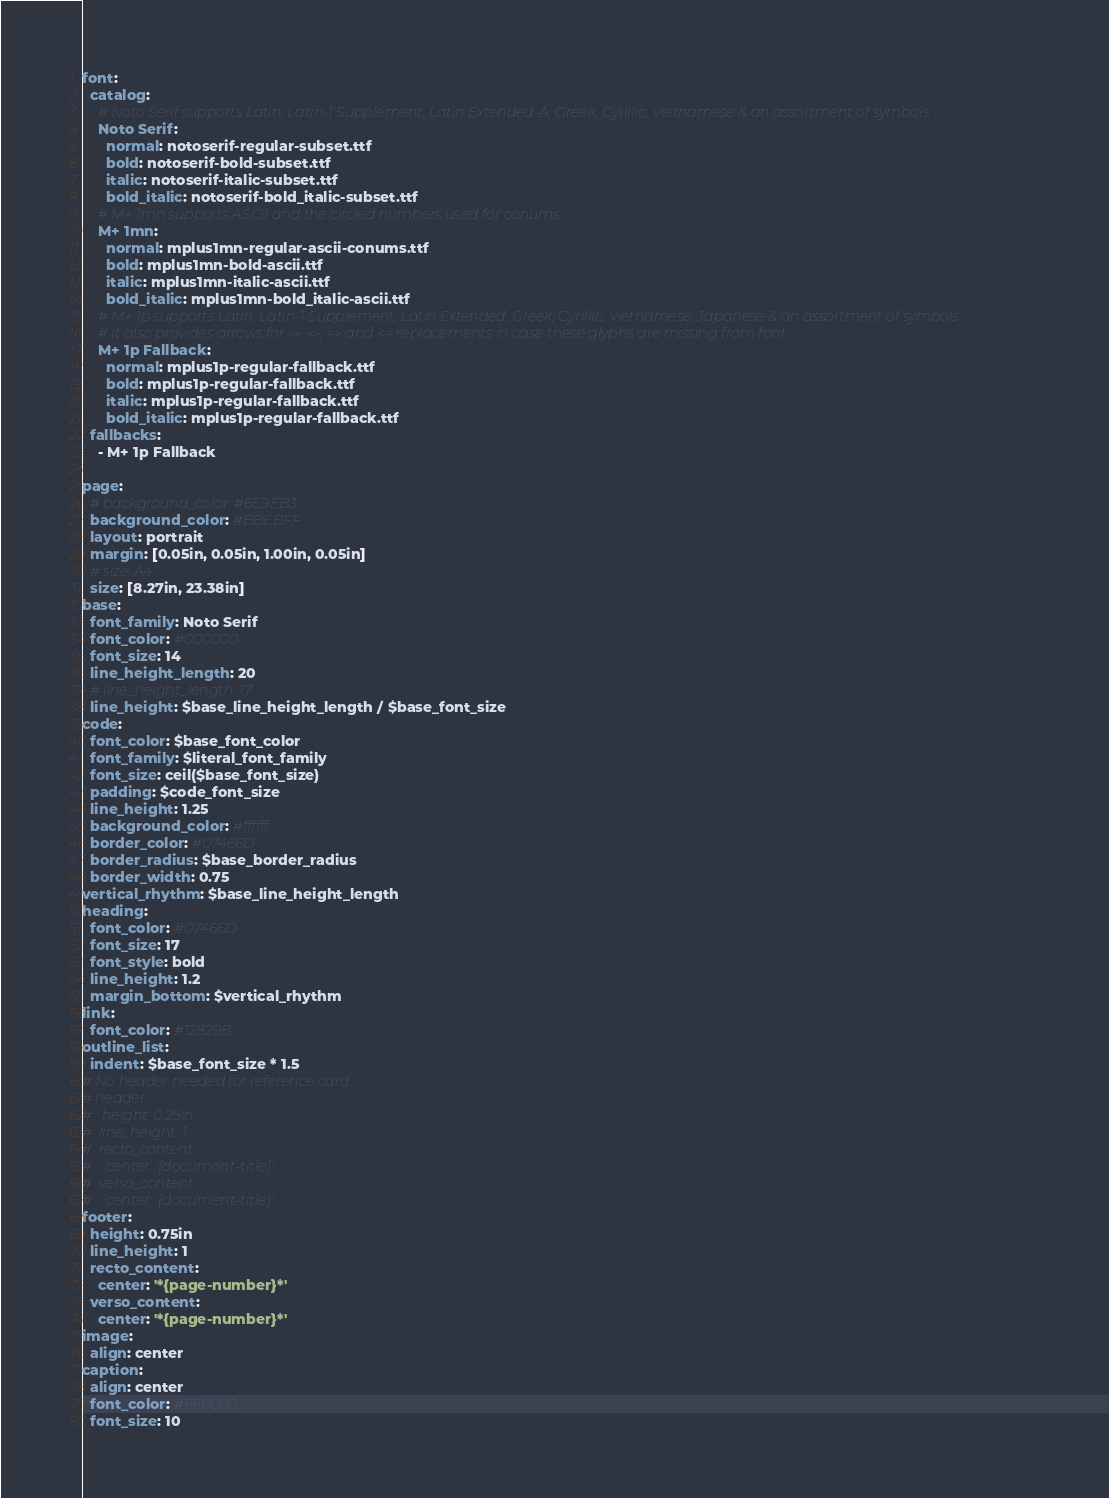Convert code to text. <code><loc_0><loc_0><loc_500><loc_500><_YAML_>font:
  catalog:
    # Noto Serif supports Latin, Latin-1 Supplement, Latin Extended-A, Greek, Cyrillic, Vietnamese & an assortment of symbols
    Noto Serif:
      normal: notoserif-regular-subset.ttf
      bold: notoserif-bold-subset.ttf
      italic: notoserif-italic-subset.ttf
      bold_italic: notoserif-bold_italic-subset.ttf
    # M+ 1mn supports ASCII and the circled numbers used for conums
    M+ 1mn:
      normal: mplus1mn-regular-ascii-conums.ttf
      bold: mplus1mn-bold-ascii.ttf
      italic: mplus1mn-italic-ascii.ttf
      bold_italic: mplus1mn-bold_italic-ascii.ttf
    # M+ 1p supports Latin, Latin-1 Supplement, Latin Extended, Greek, Cyrillic, Vietnamese, Japanese & an assortment of symbols
    # It also provides arrows for ->, <-, => and <= replacements in case these glyphs are missing from font
    M+ 1p Fallback:
      normal: mplus1p-regular-fallback.ttf
      bold: mplus1p-regular-fallback.ttf
      italic: mplus1p-regular-fallback.ttf
      bold_italic: mplus1p-regular-fallback.ttf
  fallbacks:
    - M+ 1p Fallback

page:
  # background_color: #6E9EB3
  background_color: #BBEBFF
  layout: portrait
  margin: [0.05in, 0.05in, 1.00in, 0.05in]
  # size: A4
  size: [8.27in, 23.38in]
base:
  font_family: Noto Serif
  font_color: #000000
  font_size: 14
  line_height_length: 20  
  # line_height_length: 17
  line_height: $base_line_height_length / $base_font_size
code:
  font_color: $base_font_color
  font_family: $literal_font_family
  font_size: ceil($base_font_size)
  padding: $code_font_size
  line_height: 1.25
  background_color: #ffffff
  border_color: #07466D
  border_radius: $base_border_radius
  border_width: 0.75  
vertical_rhythm: $base_line_height_length
heading:
  font_color: #07466D
  font_size: 17
  font_style: bold
  line_height: 1.2
  margin_bottom: $vertical_rhythm
link:
  font_color: #12829B
outline_list:
  indent: $base_font_size * 1.5
# No header needed for reference card  
# header:
#   height: 0.25in
#  line_height: 1
#  recto_content:
#    center: '{document-title}'
#  verso_content:
#    center: '{document-title}'
footer:
  height: 0.75in
  line_height: 1
  recto_content:
    center: '*{page-number}*'
  verso_content:
    center: '*{page-number}*'
image:
  align: center
caption:
  align: center
  font_color: #FF0000
  font_size: 10</code> 